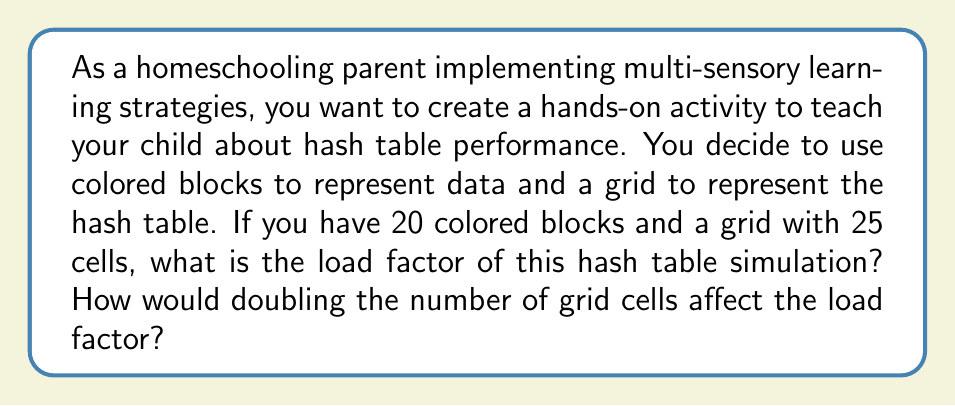Teach me how to tackle this problem. Let's break this down step-by-step:

1. Understanding load factor:
   The load factor of a hash table is defined as:
   $$ \text{Load Factor} = \frac{\text{Number of Items}}{\text{Table Size}} $$

2. Calculating the initial load factor:
   - Number of items (colored blocks) = 20
   - Table size (grid cells) = 25
   $$ \text{Initial Load Factor} = \frac{20}{25} = 0.8 $$

3. Effect of doubling the grid cells:
   - New table size = 25 * 2 = 50 cells
   - Number of items remains the same: 20
   $$ \text{New Load Factor} = \frac{20}{50} = 0.4 $$

4. Interpreting the results:
   - The initial load factor of 0.8 indicates a fairly full hash table.
   - Doubling the table size reduces the load factor by half.
   - A lower load factor generally leads to better performance, as it reduces the likelihood of collisions.

This hands-on approach allows the child to visualize how changing the table size affects the distribution of items, reinforcing the concept of load factor in a multi-sensory way.
Answer: The initial load factor is 0.8. After doubling the number of grid cells, the new load factor would be 0.4. 